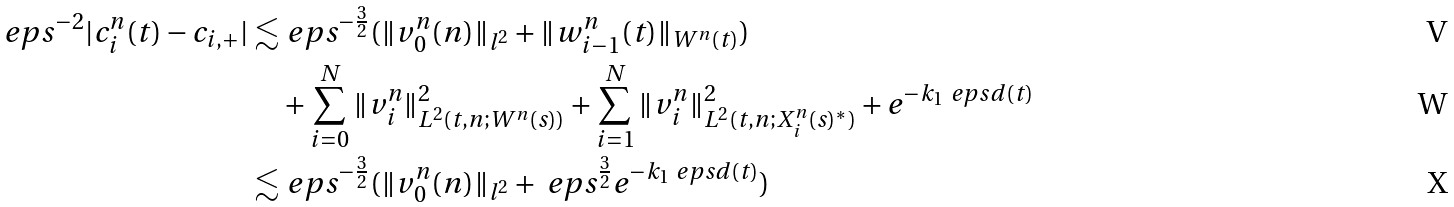Convert formula to latex. <formula><loc_0><loc_0><loc_500><loc_500>\ e p s ^ { - 2 } | c _ { i } ^ { n } ( t ) - c _ { i , + } | \lesssim & \ e p s ^ { - \frac { 3 } { 2 } } ( \| v _ { 0 } ^ { n } ( n ) \| _ { l ^ { 2 } } + \| w _ { i - 1 } ^ { n } ( t ) \| _ { W ^ { n } ( t ) } ) \\ & + \sum _ { i = 0 } ^ { N } \| v _ { i } ^ { n } \| _ { L ^ { 2 } ( t , n ; W ^ { n } ( s ) ) } ^ { 2 } + \sum _ { i = 1 } ^ { N } \| v _ { i } ^ { n } \| _ { L ^ { 2 } ( t , n ; X _ { i } ^ { n } ( s ) ^ { * } ) } ^ { 2 } + e ^ { - k _ { 1 } \ e p s d ( t ) } \\ \lesssim & \ e p s ^ { - \frac { 3 } { 2 } } ( \| v _ { 0 } ^ { n } ( n ) \| _ { l ^ { 2 } } + \ e p s ^ { \frac { 3 } { 2 } } e ^ { - k _ { 1 } \ e p s d ( t ) } )</formula> 